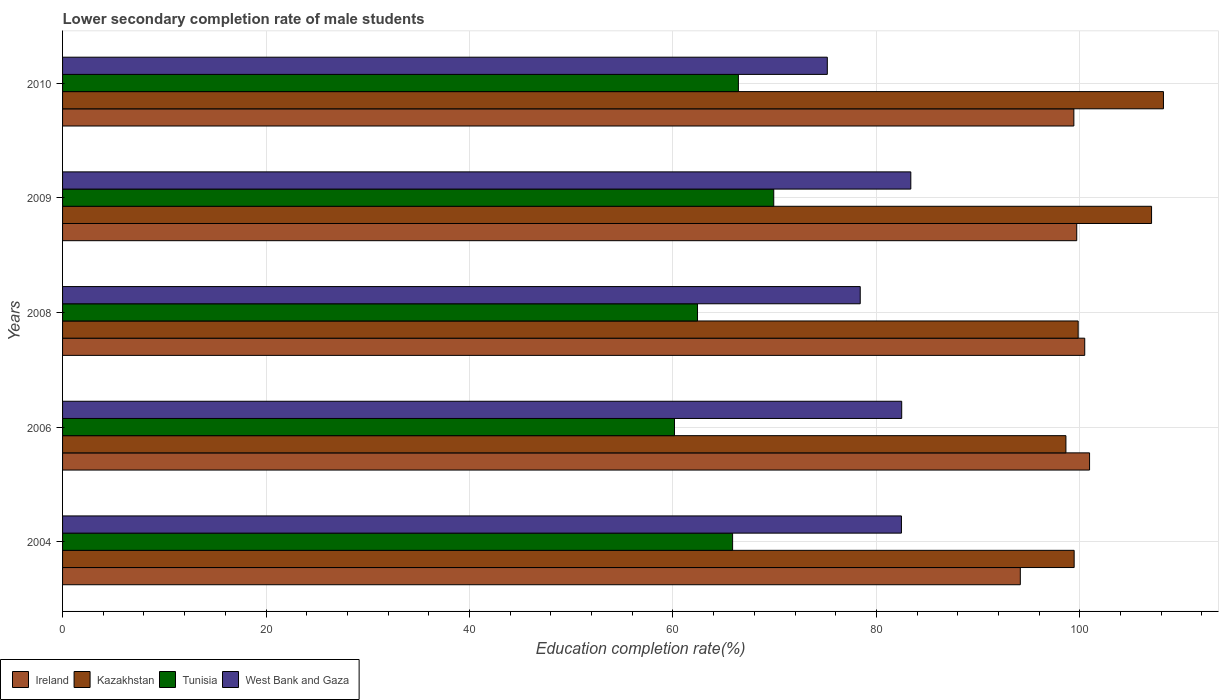How many different coloured bars are there?
Keep it short and to the point. 4. How many groups of bars are there?
Provide a succinct answer. 5. Are the number of bars on each tick of the Y-axis equal?
Give a very brief answer. Yes. In how many cases, is the number of bars for a given year not equal to the number of legend labels?
Provide a succinct answer. 0. What is the lower secondary completion rate of male students in Kazakhstan in 2004?
Ensure brevity in your answer.  99.44. Across all years, what is the maximum lower secondary completion rate of male students in West Bank and Gaza?
Give a very brief answer. 83.38. Across all years, what is the minimum lower secondary completion rate of male students in Tunisia?
Give a very brief answer. 60.15. In which year was the lower secondary completion rate of male students in Tunisia maximum?
Ensure brevity in your answer.  2009. In which year was the lower secondary completion rate of male students in Tunisia minimum?
Your response must be concise. 2006. What is the total lower secondary completion rate of male students in Tunisia in the graph?
Ensure brevity in your answer.  324.77. What is the difference between the lower secondary completion rate of male students in Kazakhstan in 2006 and that in 2010?
Give a very brief answer. -9.59. What is the difference between the lower secondary completion rate of male students in Ireland in 2004 and the lower secondary completion rate of male students in Tunisia in 2010?
Offer a terse response. 27.71. What is the average lower secondary completion rate of male students in Ireland per year?
Give a very brief answer. 98.93. In the year 2009, what is the difference between the lower secondary completion rate of male students in Kazakhstan and lower secondary completion rate of male students in Ireland?
Your answer should be compact. 7.36. In how many years, is the lower secondary completion rate of male students in West Bank and Gaza greater than 32 %?
Make the answer very short. 5. What is the ratio of the lower secondary completion rate of male students in Kazakhstan in 2008 to that in 2009?
Offer a very short reply. 0.93. Is the lower secondary completion rate of male students in Ireland in 2004 less than that in 2009?
Your answer should be compact. Yes. What is the difference between the highest and the second highest lower secondary completion rate of male students in Ireland?
Your answer should be compact. 0.47. What is the difference between the highest and the lowest lower secondary completion rate of male students in Tunisia?
Give a very brief answer. 9.76. Is the sum of the lower secondary completion rate of male students in Kazakhstan in 2008 and 2010 greater than the maximum lower secondary completion rate of male students in Tunisia across all years?
Your response must be concise. Yes. What does the 4th bar from the top in 2006 represents?
Offer a very short reply. Ireland. What does the 3rd bar from the bottom in 2006 represents?
Provide a succinct answer. Tunisia. Are the values on the major ticks of X-axis written in scientific E-notation?
Offer a very short reply. No. Does the graph contain any zero values?
Ensure brevity in your answer.  No. Does the graph contain grids?
Offer a terse response. Yes. Where does the legend appear in the graph?
Keep it short and to the point. Bottom left. How many legend labels are there?
Give a very brief answer. 4. How are the legend labels stacked?
Offer a terse response. Horizontal. What is the title of the graph?
Offer a terse response. Lower secondary completion rate of male students. What is the label or title of the X-axis?
Keep it short and to the point. Education completion rate(%). What is the Education completion rate(%) in Ireland in 2004?
Offer a terse response. 94.14. What is the Education completion rate(%) of Kazakhstan in 2004?
Offer a very short reply. 99.44. What is the Education completion rate(%) of Tunisia in 2004?
Give a very brief answer. 65.86. What is the Education completion rate(%) in West Bank and Gaza in 2004?
Make the answer very short. 82.46. What is the Education completion rate(%) of Ireland in 2006?
Provide a short and direct response. 100.95. What is the Education completion rate(%) of Kazakhstan in 2006?
Your answer should be very brief. 98.63. What is the Education completion rate(%) of Tunisia in 2006?
Provide a short and direct response. 60.15. What is the Education completion rate(%) in West Bank and Gaza in 2006?
Keep it short and to the point. 82.48. What is the Education completion rate(%) of Ireland in 2008?
Offer a terse response. 100.48. What is the Education completion rate(%) in Kazakhstan in 2008?
Offer a very short reply. 99.83. What is the Education completion rate(%) in Tunisia in 2008?
Offer a terse response. 62.41. What is the Education completion rate(%) of West Bank and Gaza in 2008?
Offer a terse response. 78.41. What is the Education completion rate(%) in Ireland in 2009?
Your answer should be compact. 99.69. What is the Education completion rate(%) in Kazakhstan in 2009?
Your answer should be compact. 107.04. What is the Education completion rate(%) in Tunisia in 2009?
Your answer should be very brief. 69.91. What is the Education completion rate(%) of West Bank and Gaza in 2009?
Provide a succinct answer. 83.38. What is the Education completion rate(%) of Ireland in 2010?
Provide a succinct answer. 99.41. What is the Education completion rate(%) of Kazakhstan in 2010?
Keep it short and to the point. 108.21. What is the Education completion rate(%) in Tunisia in 2010?
Give a very brief answer. 66.43. What is the Education completion rate(%) in West Bank and Gaza in 2010?
Give a very brief answer. 75.17. Across all years, what is the maximum Education completion rate(%) in Ireland?
Make the answer very short. 100.95. Across all years, what is the maximum Education completion rate(%) of Kazakhstan?
Offer a very short reply. 108.21. Across all years, what is the maximum Education completion rate(%) in Tunisia?
Provide a succinct answer. 69.91. Across all years, what is the maximum Education completion rate(%) of West Bank and Gaza?
Your answer should be very brief. 83.38. Across all years, what is the minimum Education completion rate(%) in Ireland?
Your answer should be very brief. 94.14. Across all years, what is the minimum Education completion rate(%) of Kazakhstan?
Keep it short and to the point. 98.63. Across all years, what is the minimum Education completion rate(%) of Tunisia?
Your answer should be compact. 60.15. Across all years, what is the minimum Education completion rate(%) in West Bank and Gaza?
Offer a terse response. 75.17. What is the total Education completion rate(%) in Ireland in the graph?
Ensure brevity in your answer.  494.67. What is the total Education completion rate(%) in Kazakhstan in the graph?
Keep it short and to the point. 513.15. What is the total Education completion rate(%) in Tunisia in the graph?
Keep it short and to the point. 324.77. What is the total Education completion rate(%) in West Bank and Gaza in the graph?
Offer a very short reply. 401.9. What is the difference between the Education completion rate(%) of Ireland in 2004 and that in 2006?
Provide a succinct answer. -6.81. What is the difference between the Education completion rate(%) in Kazakhstan in 2004 and that in 2006?
Your answer should be compact. 0.81. What is the difference between the Education completion rate(%) of Tunisia in 2004 and that in 2006?
Offer a terse response. 5.71. What is the difference between the Education completion rate(%) of West Bank and Gaza in 2004 and that in 2006?
Your response must be concise. -0.03. What is the difference between the Education completion rate(%) in Ireland in 2004 and that in 2008?
Give a very brief answer. -6.33. What is the difference between the Education completion rate(%) in Kazakhstan in 2004 and that in 2008?
Keep it short and to the point. -0.39. What is the difference between the Education completion rate(%) of Tunisia in 2004 and that in 2008?
Ensure brevity in your answer.  3.45. What is the difference between the Education completion rate(%) of West Bank and Gaza in 2004 and that in 2008?
Ensure brevity in your answer.  4.05. What is the difference between the Education completion rate(%) of Ireland in 2004 and that in 2009?
Provide a succinct answer. -5.54. What is the difference between the Education completion rate(%) in Kazakhstan in 2004 and that in 2009?
Provide a succinct answer. -7.61. What is the difference between the Education completion rate(%) in Tunisia in 2004 and that in 2009?
Give a very brief answer. -4.04. What is the difference between the Education completion rate(%) in West Bank and Gaza in 2004 and that in 2009?
Provide a succinct answer. -0.92. What is the difference between the Education completion rate(%) in Ireland in 2004 and that in 2010?
Your answer should be very brief. -5.26. What is the difference between the Education completion rate(%) in Kazakhstan in 2004 and that in 2010?
Your response must be concise. -8.78. What is the difference between the Education completion rate(%) of Tunisia in 2004 and that in 2010?
Your answer should be compact. -0.57. What is the difference between the Education completion rate(%) of West Bank and Gaza in 2004 and that in 2010?
Your answer should be compact. 7.29. What is the difference between the Education completion rate(%) of Ireland in 2006 and that in 2008?
Offer a very short reply. 0.47. What is the difference between the Education completion rate(%) of Kazakhstan in 2006 and that in 2008?
Ensure brevity in your answer.  -1.2. What is the difference between the Education completion rate(%) of Tunisia in 2006 and that in 2008?
Your answer should be very brief. -2.26. What is the difference between the Education completion rate(%) in West Bank and Gaza in 2006 and that in 2008?
Keep it short and to the point. 4.08. What is the difference between the Education completion rate(%) in Ireland in 2006 and that in 2009?
Provide a short and direct response. 1.26. What is the difference between the Education completion rate(%) of Kazakhstan in 2006 and that in 2009?
Your answer should be very brief. -8.42. What is the difference between the Education completion rate(%) in Tunisia in 2006 and that in 2009?
Provide a succinct answer. -9.76. What is the difference between the Education completion rate(%) in West Bank and Gaza in 2006 and that in 2009?
Your answer should be compact. -0.9. What is the difference between the Education completion rate(%) in Ireland in 2006 and that in 2010?
Ensure brevity in your answer.  1.54. What is the difference between the Education completion rate(%) in Kazakhstan in 2006 and that in 2010?
Offer a very short reply. -9.59. What is the difference between the Education completion rate(%) in Tunisia in 2006 and that in 2010?
Keep it short and to the point. -6.28. What is the difference between the Education completion rate(%) of West Bank and Gaza in 2006 and that in 2010?
Your response must be concise. 7.31. What is the difference between the Education completion rate(%) of Ireland in 2008 and that in 2009?
Keep it short and to the point. 0.79. What is the difference between the Education completion rate(%) of Kazakhstan in 2008 and that in 2009?
Your response must be concise. -7.21. What is the difference between the Education completion rate(%) of Tunisia in 2008 and that in 2009?
Provide a short and direct response. -7.49. What is the difference between the Education completion rate(%) of West Bank and Gaza in 2008 and that in 2009?
Make the answer very short. -4.97. What is the difference between the Education completion rate(%) of Ireland in 2008 and that in 2010?
Offer a very short reply. 1.07. What is the difference between the Education completion rate(%) in Kazakhstan in 2008 and that in 2010?
Offer a very short reply. -8.38. What is the difference between the Education completion rate(%) of Tunisia in 2008 and that in 2010?
Offer a very short reply. -4.02. What is the difference between the Education completion rate(%) in West Bank and Gaza in 2008 and that in 2010?
Your response must be concise. 3.24. What is the difference between the Education completion rate(%) in Ireland in 2009 and that in 2010?
Provide a short and direct response. 0.28. What is the difference between the Education completion rate(%) in Kazakhstan in 2009 and that in 2010?
Your response must be concise. -1.17. What is the difference between the Education completion rate(%) of Tunisia in 2009 and that in 2010?
Your response must be concise. 3.48. What is the difference between the Education completion rate(%) of West Bank and Gaza in 2009 and that in 2010?
Your response must be concise. 8.21. What is the difference between the Education completion rate(%) of Ireland in 2004 and the Education completion rate(%) of Kazakhstan in 2006?
Make the answer very short. -4.48. What is the difference between the Education completion rate(%) in Ireland in 2004 and the Education completion rate(%) in Tunisia in 2006?
Keep it short and to the point. 33.99. What is the difference between the Education completion rate(%) of Ireland in 2004 and the Education completion rate(%) of West Bank and Gaza in 2006?
Offer a very short reply. 11.66. What is the difference between the Education completion rate(%) in Kazakhstan in 2004 and the Education completion rate(%) in Tunisia in 2006?
Ensure brevity in your answer.  39.29. What is the difference between the Education completion rate(%) in Kazakhstan in 2004 and the Education completion rate(%) in West Bank and Gaza in 2006?
Make the answer very short. 16.95. What is the difference between the Education completion rate(%) in Tunisia in 2004 and the Education completion rate(%) in West Bank and Gaza in 2006?
Give a very brief answer. -16.62. What is the difference between the Education completion rate(%) of Ireland in 2004 and the Education completion rate(%) of Kazakhstan in 2008?
Your response must be concise. -5.69. What is the difference between the Education completion rate(%) of Ireland in 2004 and the Education completion rate(%) of Tunisia in 2008?
Offer a very short reply. 31.73. What is the difference between the Education completion rate(%) of Ireland in 2004 and the Education completion rate(%) of West Bank and Gaza in 2008?
Your answer should be very brief. 15.74. What is the difference between the Education completion rate(%) of Kazakhstan in 2004 and the Education completion rate(%) of Tunisia in 2008?
Your response must be concise. 37.02. What is the difference between the Education completion rate(%) in Kazakhstan in 2004 and the Education completion rate(%) in West Bank and Gaza in 2008?
Provide a succinct answer. 21.03. What is the difference between the Education completion rate(%) of Tunisia in 2004 and the Education completion rate(%) of West Bank and Gaza in 2008?
Provide a short and direct response. -12.54. What is the difference between the Education completion rate(%) in Ireland in 2004 and the Education completion rate(%) in Kazakhstan in 2009?
Give a very brief answer. -12.9. What is the difference between the Education completion rate(%) in Ireland in 2004 and the Education completion rate(%) in Tunisia in 2009?
Offer a very short reply. 24.24. What is the difference between the Education completion rate(%) of Ireland in 2004 and the Education completion rate(%) of West Bank and Gaza in 2009?
Your answer should be very brief. 10.76. What is the difference between the Education completion rate(%) of Kazakhstan in 2004 and the Education completion rate(%) of Tunisia in 2009?
Give a very brief answer. 29.53. What is the difference between the Education completion rate(%) in Kazakhstan in 2004 and the Education completion rate(%) in West Bank and Gaza in 2009?
Provide a succinct answer. 16.06. What is the difference between the Education completion rate(%) of Tunisia in 2004 and the Education completion rate(%) of West Bank and Gaza in 2009?
Keep it short and to the point. -17.52. What is the difference between the Education completion rate(%) of Ireland in 2004 and the Education completion rate(%) of Kazakhstan in 2010?
Offer a very short reply. -14.07. What is the difference between the Education completion rate(%) in Ireland in 2004 and the Education completion rate(%) in Tunisia in 2010?
Ensure brevity in your answer.  27.71. What is the difference between the Education completion rate(%) in Ireland in 2004 and the Education completion rate(%) in West Bank and Gaza in 2010?
Your answer should be compact. 18.97. What is the difference between the Education completion rate(%) in Kazakhstan in 2004 and the Education completion rate(%) in Tunisia in 2010?
Your answer should be very brief. 33. What is the difference between the Education completion rate(%) of Kazakhstan in 2004 and the Education completion rate(%) of West Bank and Gaza in 2010?
Offer a very short reply. 24.26. What is the difference between the Education completion rate(%) in Tunisia in 2004 and the Education completion rate(%) in West Bank and Gaza in 2010?
Offer a very short reply. -9.31. What is the difference between the Education completion rate(%) of Ireland in 2006 and the Education completion rate(%) of Kazakhstan in 2008?
Make the answer very short. 1.12. What is the difference between the Education completion rate(%) in Ireland in 2006 and the Education completion rate(%) in Tunisia in 2008?
Offer a very short reply. 38.54. What is the difference between the Education completion rate(%) in Ireland in 2006 and the Education completion rate(%) in West Bank and Gaza in 2008?
Your answer should be very brief. 22.54. What is the difference between the Education completion rate(%) of Kazakhstan in 2006 and the Education completion rate(%) of Tunisia in 2008?
Your response must be concise. 36.21. What is the difference between the Education completion rate(%) of Kazakhstan in 2006 and the Education completion rate(%) of West Bank and Gaza in 2008?
Offer a terse response. 20.22. What is the difference between the Education completion rate(%) in Tunisia in 2006 and the Education completion rate(%) in West Bank and Gaza in 2008?
Your answer should be very brief. -18.26. What is the difference between the Education completion rate(%) in Ireland in 2006 and the Education completion rate(%) in Kazakhstan in 2009?
Your response must be concise. -6.09. What is the difference between the Education completion rate(%) in Ireland in 2006 and the Education completion rate(%) in Tunisia in 2009?
Your answer should be very brief. 31.04. What is the difference between the Education completion rate(%) in Ireland in 2006 and the Education completion rate(%) in West Bank and Gaza in 2009?
Offer a very short reply. 17.57. What is the difference between the Education completion rate(%) of Kazakhstan in 2006 and the Education completion rate(%) of Tunisia in 2009?
Your answer should be very brief. 28.72. What is the difference between the Education completion rate(%) in Kazakhstan in 2006 and the Education completion rate(%) in West Bank and Gaza in 2009?
Provide a succinct answer. 15.25. What is the difference between the Education completion rate(%) in Tunisia in 2006 and the Education completion rate(%) in West Bank and Gaza in 2009?
Offer a very short reply. -23.23. What is the difference between the Education completion rate(%) in Ireland in 2006 and the Education completion rate(%) in Kazakhstan in 2010?
Make the answer very short. -7.26. What is the difference between the Education completion rate(%) of Ireland in 2006 and the Education completion rate(%) of Tunisia in 2010?
Give a very brief answer. 34.52. What is the difference between the Education completion rate(%) of Ireland in 2006 and the Education completion rate(%) of West Bank and Gaza in 2010?
Offer a terse response. 25.78. What is the difference between the Education completion rate(%) in Kazakhstan in 2006 and the Education completion rate(%) in Tunisia in 2010?
Your answer should be very brief. 32.2. What is the difference between the Education completion rate(%) in Kazakhstan in 2006 and the Education completion rate(%) in West Bank and Gaza in 2010?
Keep it short and to the point. 23.46. What is the difference between the Education completion rate(%) of Tunisia in 2006 and the Education completion rate(%) of West Bank and Gaza in 2010?
Offer a very short reply. -15.02. What is the difference between the Education completion rate(%) of Ireland in 2008 and the Education completion rate(%) of Kazakhstan in 2009?
Offer a very short reply. -6.57. What is the difference between the Education completion rate(%) of Ireland in 2008 and the Education completion rate(%) of Tunisia in 2009?
Provide a short and direct response. 30.57. What is the difference between the Education completion rate(%) of Ireland in 2008 and the Education completion rate(%) of West Bank and Gaza in 2009?
Keep it short and to the point. 17.1. What is the difference between the Education completion rate(%) of Kazakhstan in 2008 and the Education completion rate(%) of Tunisia in 2009?
Provide a succinct answer. 29.92. What is the difference between the Education completion rate(%) in Kazakhstan in 2008 and the Education completion rate(%) in West Bank and Gaza in 2009?
Provide a short and direct response. 16.45. What is the difference between the Education completion rate(%) in Tunisia in 2008 and the Education completion rate(%) in West Bank and Gaza in 2009?
Give a very brief answer. -20.97. What is the difference between the Education completion rate(%) in Ireland in 2008 and the Education completion rate(%) in Kazakhstan in 2010?
Make the answer very short. -7.74. What is the difference between the Education completion rate(%) of Ireland in 2008 and the Education completion rate(%) of Tunisia in 2010?
Keep it short and to the point. 34.04. What is the difference between the Education completion rate(%) in Ireland in 2008 and the Education completion rate(%) in West Bank and Gaza in 2010?
Your answer should be very brief. 25.3. What is the difference between the Education completion rate(%) of Kazakhstan in 2008 and the Education completion rate(%) of Tunisia in 2010?
Offer a terse response. 33.4. What is the difference between the Education completion rate(%) of Kazakhstan in 2008 and the Education completion rate(%) of West Bank and Gaza in 2010?
Your response must be concise. 24.66. What is the difference between the Education completion rate(%) in Tunisia in 2008 and the Education completion rate(%) in West Bank and Gaza in 2010?
Ensure brevity in your answer.  -12.76. What is the difference between the Education completion rate(%) in Ireland in 2009 and the Education completion rate(%) in Kazakhstan in 2010?
Give a very brief answer. -8.52. What is the difference between the Education completion rate(%) in Ireland in 2009 and the Education completion rate(%) in Tunisia in 2010?
Give a very brief answer. 33.26. What is the difference between the Education completion rate(%) of Ireland in 2009 and the Education completion rate(%) of West Bank and Gaza in 2010?
Ensure brevity in your answer.  24.52. What is the difference between the Education completion rate(%) of Kazakhstan in 2009 and the Education completion rate(%) of Tunisia in 2010?
Your answer should be very brief. 40.61. What is the difference between the Education completion rate(%) of Kazakhstan in 2009 and the Education completion rate(%) of West Bank and Gaza in 2010?
Provide a succinct answer. 31.87. What is the difference between the Education completion rate(%) of Tunisia in 2009 and the Education completion rate(%) of West Bank and Gaza in 2010?
Ensure brevity in your answer.  -5.26. What is the average Education completion rate(%) in Ireland per year?
Give a very brief answer. 98.93. What is the average Education completion rate(%) of Kazakhstan per year?
Make the answer very short. 102.63. What is the average Education completion rate(%) of Tunisia per year?
Keep it short and to the point. 64.95. What is the average Education completion rate(%) of West Bank and Gaza per year?
Ensure brevity in your answer.  80.38. In the year 2004, what is the difference between the Education completion rate(%) of Ireland and Education completion rate(%) of Kazakhstan?
Keep it short and to the point. -5.29. In the year 2004, what is the difference between the Education completion rate(%) of Ireland and Education completion rate(%) of Tunisia?
Offer a very short reply. 28.28. In the year 2004, what is the difference between the Education completion rate(%) in Ireland and Education completion rate(%) in West Bank and Gaza?
Your response must be concise. 11.69. In the year 2004, what is the difference between the Education completion rate(%) of Kazakhstan and Education completion rate(%) of Tunisia?
Your answer should be compact. 33.57. In the year 2004, what is the difference between the Education completion rate(%) in Kazakhstan and Education completion rate(%) in West Bank and Gaza?
Your answer should be very brief. 16.98. In the year 2004, what is the difference between the Education completion rate(%) in Tunisia and Education completion rate(%) in West Bank and Gaza?
Ensure brevity in your answer.  -16.59. In the year 2006, what is the difference between the Education completion rate(%) in Ireland and Education completion rate(%) in Kazakhstan?
Provide a short and direct response. 2.32. In the year 2006, what is the difference between the Education completion rate(%) in Ireland and Education completion rate(%) in Tunisia?
Provide a short and direct response. 40.8. In the year 2006, what is the difference between the Education completion rate(%) of Ireland and Education completion rate(%) of West Bank and Gaza?
Ensure brevity in your answer.  18.47. In the year 2006, what is the difference between the Education completion rate(%) of Kazakhstan and Education completion rate(%) of Tunisia?
Your answer should be very brief. 38.48. In the year 2006, what is the difference between the Education completion rate(%) in Kazakhstan and Education completion rate(%) in West Bank and Gaza?
Your answer should be compact. 16.14. In the year 2006, what is the difference between the Education completion rate(%) of Tunisia and Education completion rate(%) of West Bank and Gaza?
Make the answer very short. -22.34. In the year 2008, what is the difference between the Education completion rate(%) of Ireland and Education completion rate(%) of Kazakhstan?
Ensure brevity in your answer.  0.65. In the year 2008, what is the difference between the Education completion rate(%) in Ireland and Education completion rate(%) in Tunisia?
Offer a terse response. 38.06. In the year 2008, what is the difference between the Education completion rate(%) of Ireland and Education completion rate(%) of West Bank and Gaza?
Give a very brief answer. 22.07. In the year 2008, what is the difference between the Education completion rate(%) in Kazakhstan and Education completion rate(%) in Tunisia?
Offer a very short reply. 37.42. In the year 2008, what is the difference between the Education completion rate(%) of Kazakhstan and Education completion rate(%) of West Bank and Gaza?
Provide a succinct answer. 21.42. In the year 2008, what is the difference between the Education completion rate(%) of Tunisia and Education completion rate(%) of West Bank and Gaza?
Offer a very short reply. -15.99. In the year 2009, what is the difference between the Education completion rate(%) of Ireland and Education completion rate(%) of Kazakhstan?
Offer a terse response. -7.36. In the year 2009, what is the difference between the Education completion rate(%) of Ireland and Education completion rate(%) of Tunisia?
Provide a succinct answer. 29.78. In the year 2009, what is the difference between the Education completion rate(%) of Ireland and Education completion rate(%) of West Bank and Gaza?
Your answer should be compact. 16.31. In the year 2009, what is the difference between the Education completion rate(%) in Kazakhstan and Education completion rate(%) in Tunisia?
Give a very brief answer. 37.14. In the year 2009, what is the difference between the Education completion rate(%) in Kazakhstan and Education completion rate(%) in West Bank and Gaza?
Your response must be concise. 23.66. In the year 2009, what is the difference between the Education completion rate(%) of Tunisia and Education completion rate(%) of West Bank and Gaza?
Provide a short and direct response. -13.47. In the year 2010, what is the difference between the Education completion rate(%) of Ireland and Education completion rate(%) of Kazakhstan?
Give a very brief answer. -8.81. In the year 2010, what is the difference between the Education completion rate(%) in Ireland and Education completion rate(%) in Tunisia?
Ensure brevity in your answer.  32.98. In the year 2010, what is the difference between the Education completion rate(%) in Ireland and Education completion rate(%) in West Bank and Gaza?
Keep it short and to the point. 24.24. In the year 2010, what is the difference between the Education completion rate(%) in Kazakhstan and Education completion rate(%) in Tunisia?
Your answer should be very brief. 41.78. In the year 2010, what is the difference between the Education completion rate(%) in Kazakhstan and Education completion rate(%) in West Bank and Gaza?
Provide a succinct answer. 33.04. In the year 2010, what is the difference between the Education completion rate(%) in Tunisia and Education completion rate(%) in West Bank and Gaza?
Keep it short and to the point. -8.74. What is the ratio of the Education completion rate(%) of Ireland in 2004 to that in 2006?
Offer a very short reply. 0.93. What is the ratio of the Education completion rate(%) of Kazakhstan in 2004 to that in 2006?
Your response must be concise. 1.01. What is the ratio of the Education completion rate(%) of Tunisia in 2004 to that in 2006?
Offer a terse response. 1.09. What is the ratio of the Education completion rate(%) of West Bank and Gaza in 2004 to that in 2006?
Ensure brevity in your answer.  1. What is the ratio of the Education completion rate(%) in Ireland in 2004 to that in 2008?
Offer a terse response. 0.94. What is the ratio of the Education completion rate(%) in Kazakhstan in 2004 to that in 2008?
Ensure brevity in your answer.  1. What is the ratio of the Education completion rate(%) of Tunisia in 2004 to that in 2008?
Your answer should be very brief. 1.06. What is the ratio of the Education completion rate(%) in West Bank and Gaza in 2004 to that in 2008?
Keep it short and to the point. 1.05. What is the ratio of the Education completion rate(%) in Kazakhstan in 2004 to that in 2009?
Provide a short and direct response. 0.93. What is the ratio of the Education completion rate(%) of Tunisia in 2004 to that in 2009?
Provide a short and direct response. 0.94. What is the ratio of the Education completion rate(%) of West Bank and Gaza in 2004 to that in 2009?
Give a very brief answer. 0.99. What is the ratio of the Education completion rate(%) of Ireland in 2004 to that in 2010?
Ensure brevity in your answer.  0.95. What is the ratio of the Education completion rate(%) in Kazakhstan in 2004 to that in 2010?
Offer a very short reply. 0.92. What is the ratio of the Education completion rate(%) in Tunisia in 2004 to that in 2010?
Keep it short and to the point. 0.99. What is the ratio of the Education completion rate(%) in West Bank and Gaza in 2004 to that in 2010?
Your response must be concise. 1.1. What is the ratio of the Education completion rate(%) of Ireland in 2006 to that in 2008?
Your answer should be compact. 1. What is the ratio of the Education completion rate(%) in Kazakhstan in 2006 to that in 2008?
Your answer should be compact. 0.99. What is the ratio of the Education completion rate(%) of Tunisia in 2006 to that in 2008?
Your response must be concise. 0.96. What is the ratio of the Education completion rate(%) of West Bank and Gaza in 2006 to that in 2008?
Give a very brief answer. 1.05. What is the ratio of the Education completion rate(%) of Ireland in 2006 to that in 2009?
Offer a very short reply. 1.01. What is the ratio of the Education completion rate(%) in Kazakhstan in 2006 to that in 2009?
Provide a succinct answer. 0.92. What is the ratio of the Education completion rate(%) of Tunisia in 2006 to that in 2009?
Make the answer very short. 0.86. What is the ratio of the Education completion rate(%) of West Bank and Gaza in 2006 to that in 2009?
Offer a very short reply. 0.99. What is the ratio of the Education completion rate(%) of Ireland in 2006 to that in 2010?
Your response must be concise. 1.02. What is the ratio of the Education completion rate(%) of Kazakhstan in 2006 to that in 2010?
Ensure brevity in your answer.  0.91. What is the ratio of the Education completion rate(%) of Tunisia in 2006 to that in 2010?
Provide a short and direct response. 0.91. What is the ratio of the Education completion rate(%) in West Bank and Gaza in 2006 to that in 2010?
Your answer should be very brief. 1.1. What is the ratio of the Education completion rate(%) in Ireland in 2008 to that in 2009?
Offer a terse response. 1.01. What is the ratio of the Education completion rate(%) in Kazakhstan in 2008 to that in 2009?
Keep it short and to the point. 0.93. What is the ratio of the Education completion rate(%) of Tunisia in 2008 to that in 2009?
Provide a succinct answer. 0.89. What is the ratio of the Education completion rate(%) of West Bank and Gaza in 2008 to that in 2009?
Keep it short and to the point. 0.94. What is the ratio of the Education completion rate(%) in Ireland in 2008 to that in 2010?
Your answer should be very brief. 1.01. What is the ratio of the Education completion rate(%) in Kazakhstan in 2008 to that in 2010?
Provide a succinct answer. 0.92. What is the ratio of the Education completion rate(%) of Tunisia in 2008 to that in 2010?
Offer a very short reply. 0.94. What is the ratio of the Education completion rate(%) of West Bank and Gaza in 2008 to that in 2010?
Provide a short and direct response. 1.04. What is the ratio of the Education completion rate(%) in Tunisia in 2009 to that in 2010?
Ensure brevity in your answer.  1.05. What is the ratio of the Education completion rate(%) of West Bank and Gaza in 2009 to that in 2010?
Your response must be concise. 1.11. What is the difference between the highest and the second highest Education completion rate(%) of Ireland?
Provide a succinct answer. 0.47. What is the difference between the highest and the second highest Education completion rate(%) of Kazakhstan?
Your answer should be very brief. 1.17. What is the difference between the highest and the second highest Education completion rate(%) in Tunisia?
Keep it short and to the point. 3.48. What is the difference between the highest and the second highest Education completion rate(%) in West Bank and Gaza?
Provide a short and direct response. 0.9. What is the difference between the highest and the lowest Education completion rate(%) in Ireland?
Provide a short and direct response. 6.81. What is the difference between the highest and the lowest Education completion rate(%) in Kazakhstan?
Your answer should be very brief. 9.59. What is the difference between the highest and the lowest Education completion rate(%) of Tunisia?
Keep it short and to the point. 9.76. What is the difference between the highest and the lowest Education completion rate(%) in West Bank and Gaza?
Offer a very short reply. 8.21. 